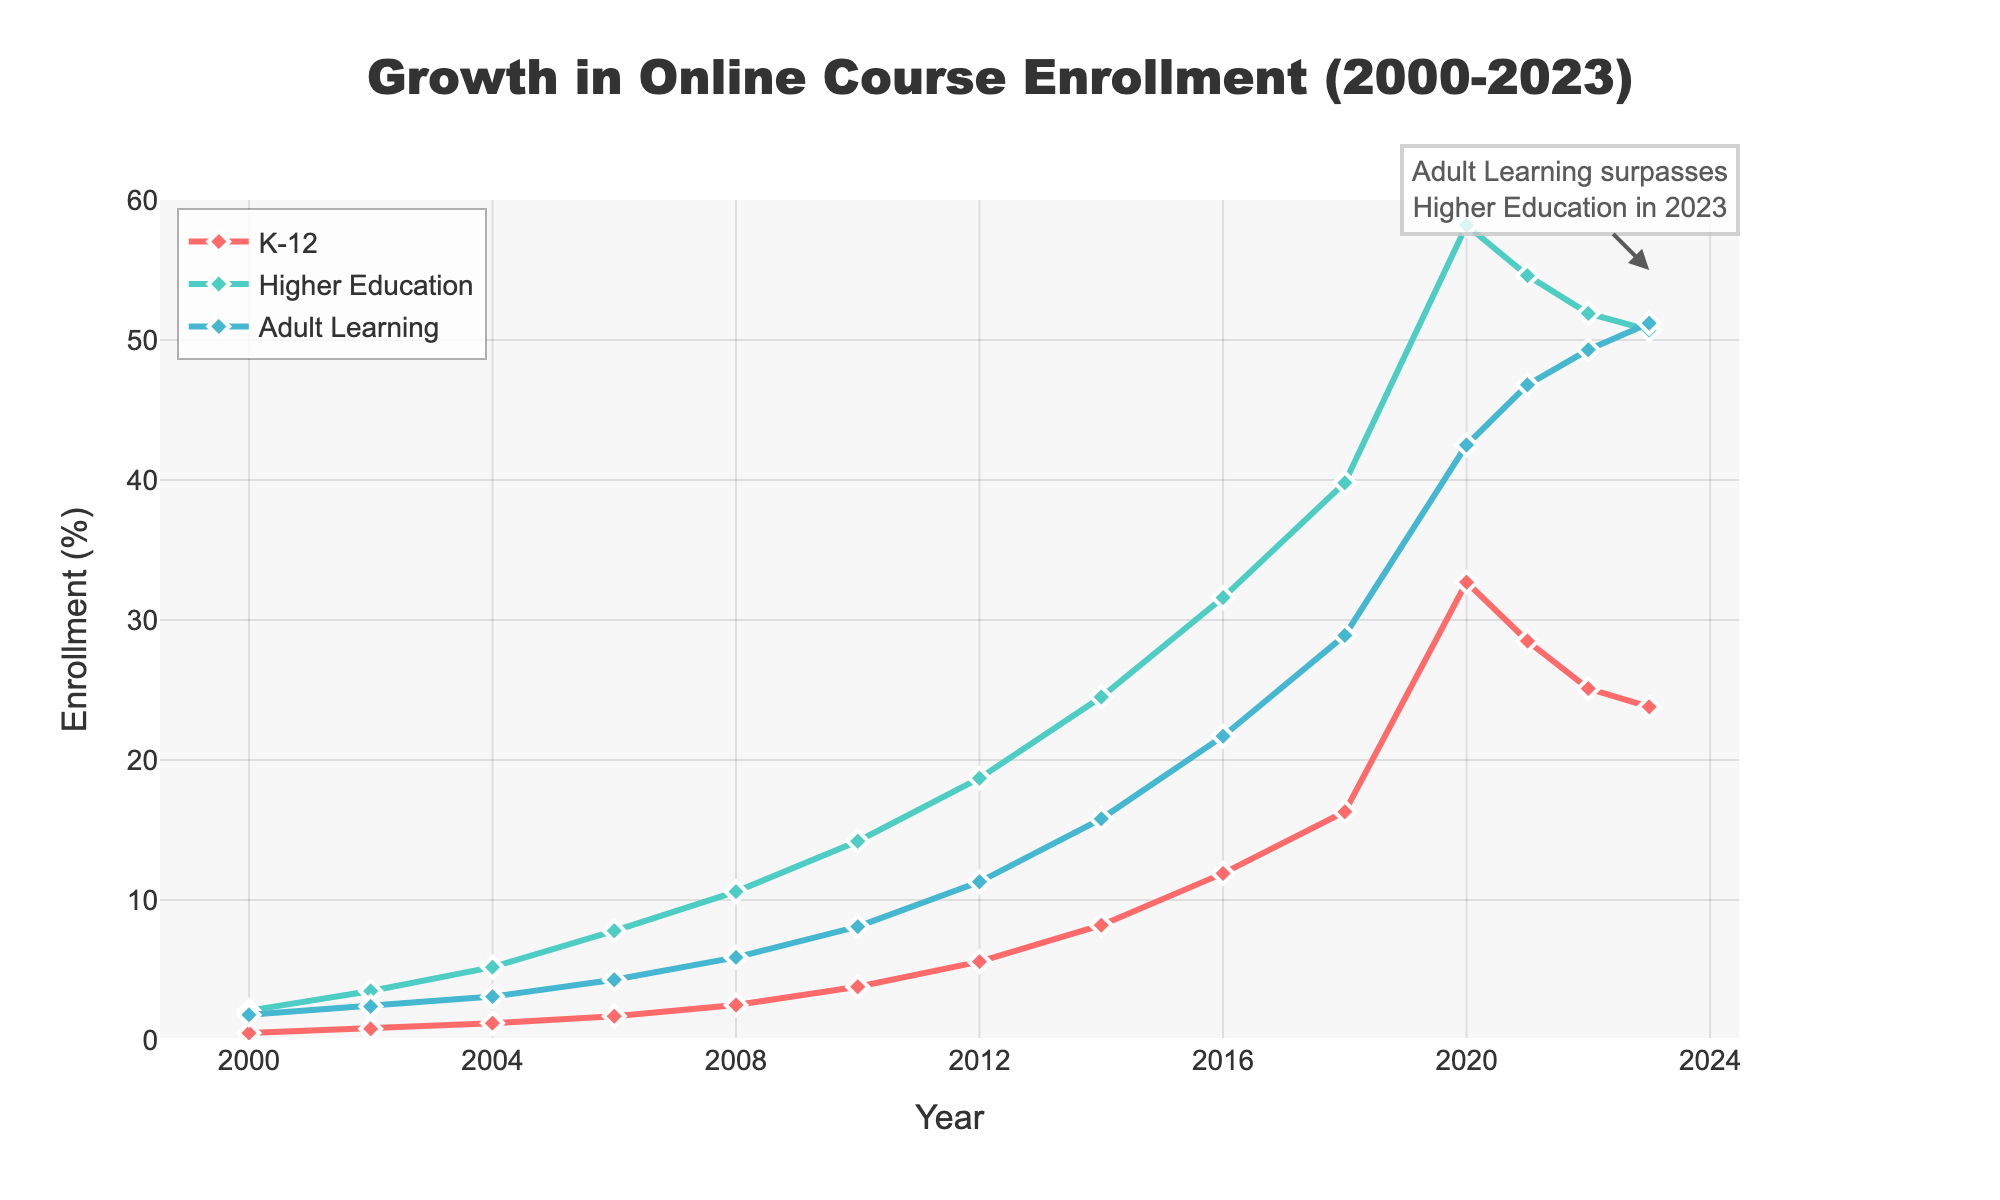What year did Adult Learning surpass Higher Education in enrollment? In the figure, there is a clear annotation pointing out that Adult Learning surpasses Higher Education in enrollment in the year 2023.
Answer: 2023 Which age group had the most significant growth in online course enrollment from 2000 to 2023? To identify the age group with the most significant growth, compare the values of each group in 2000 and 2023. K-12 grew from 0.5% to 23.8%, Higher Education from 2.1% to 50.7%, and Adult Learning from 1.8% to 51.2%. Adult Learning exhibited the highest increase over the period.
Answer: Adult Learning Which year showed the peak enrollment for K-12? By examining the peak of the K-12 line on the chart, it reaches its highest point in the year 2020 at 32.7%.
Answer: 2020 How does the enrollment trend of Higher Education change between 2020 and 2023? Observing the Higher Education line segment from 2020 to 2023, the trend shows a decrease from 58.2% in 2020 to 50.7% in 2023.
Answer: Decrease What was the difference in enrollment between Higher Education and Adult Learning in the year 2006? In 2006, Higher Education enrollment was 7.8% and Adult Learning enrollment was 4.3%. The difference is calculated as 7.8% - 4.3% = 3.5%.
Answer: 3.5% In which year did K-12 enrollment first exceed 10%? Looking at the K-12 line, it first exceeds 10% in the year 2016, when it reaches 11.9%.
Answer: 2016 What's the average enrollment of K-12 over the entire period from 2000 to 2023? To find the average, sum all K-12 enrollment values and divide by the number of years (14). The sum is 0.5 + 0.8 + 1.2 + 1.7 + 2.5 + 3.8 + 5.6 + 8.2 + 11.9 + 16.3 + 32.7 + 28.5 + 25.1 + 23.8 = 162.6. The average is 162.6 / 14 ≈ 11.6%.
Answer: 11.6% Which age group had the steepest increase in enrollment between any two consecutive points on the chart? Inspecting the slopes between consecutive points for each age group, K-12 has the steepest increase between 2018 (16.3%) and 2020 (32.7%) with a change of 16.4%.
Answer: K-12 How many years did it take for Higher Education enrollment to grow from 10% to 30%? Higher Education enrollment was 10.6% in 2008 and reached 31.6% in 2016. The number of years taken is 2016 - 2008 = 8 years.
Answer: 8 years Compare the trends of K-12 and Adult Learning from 2020 to 2023. Both K-12 and Adult Learning show a decline, but K-12 has a sharper decrease from 32.7% to 23.8%, while Adult Learning decreases more slowly from 42.5% to 51.2%.
Answer: Both decrease, K-12 sharper 